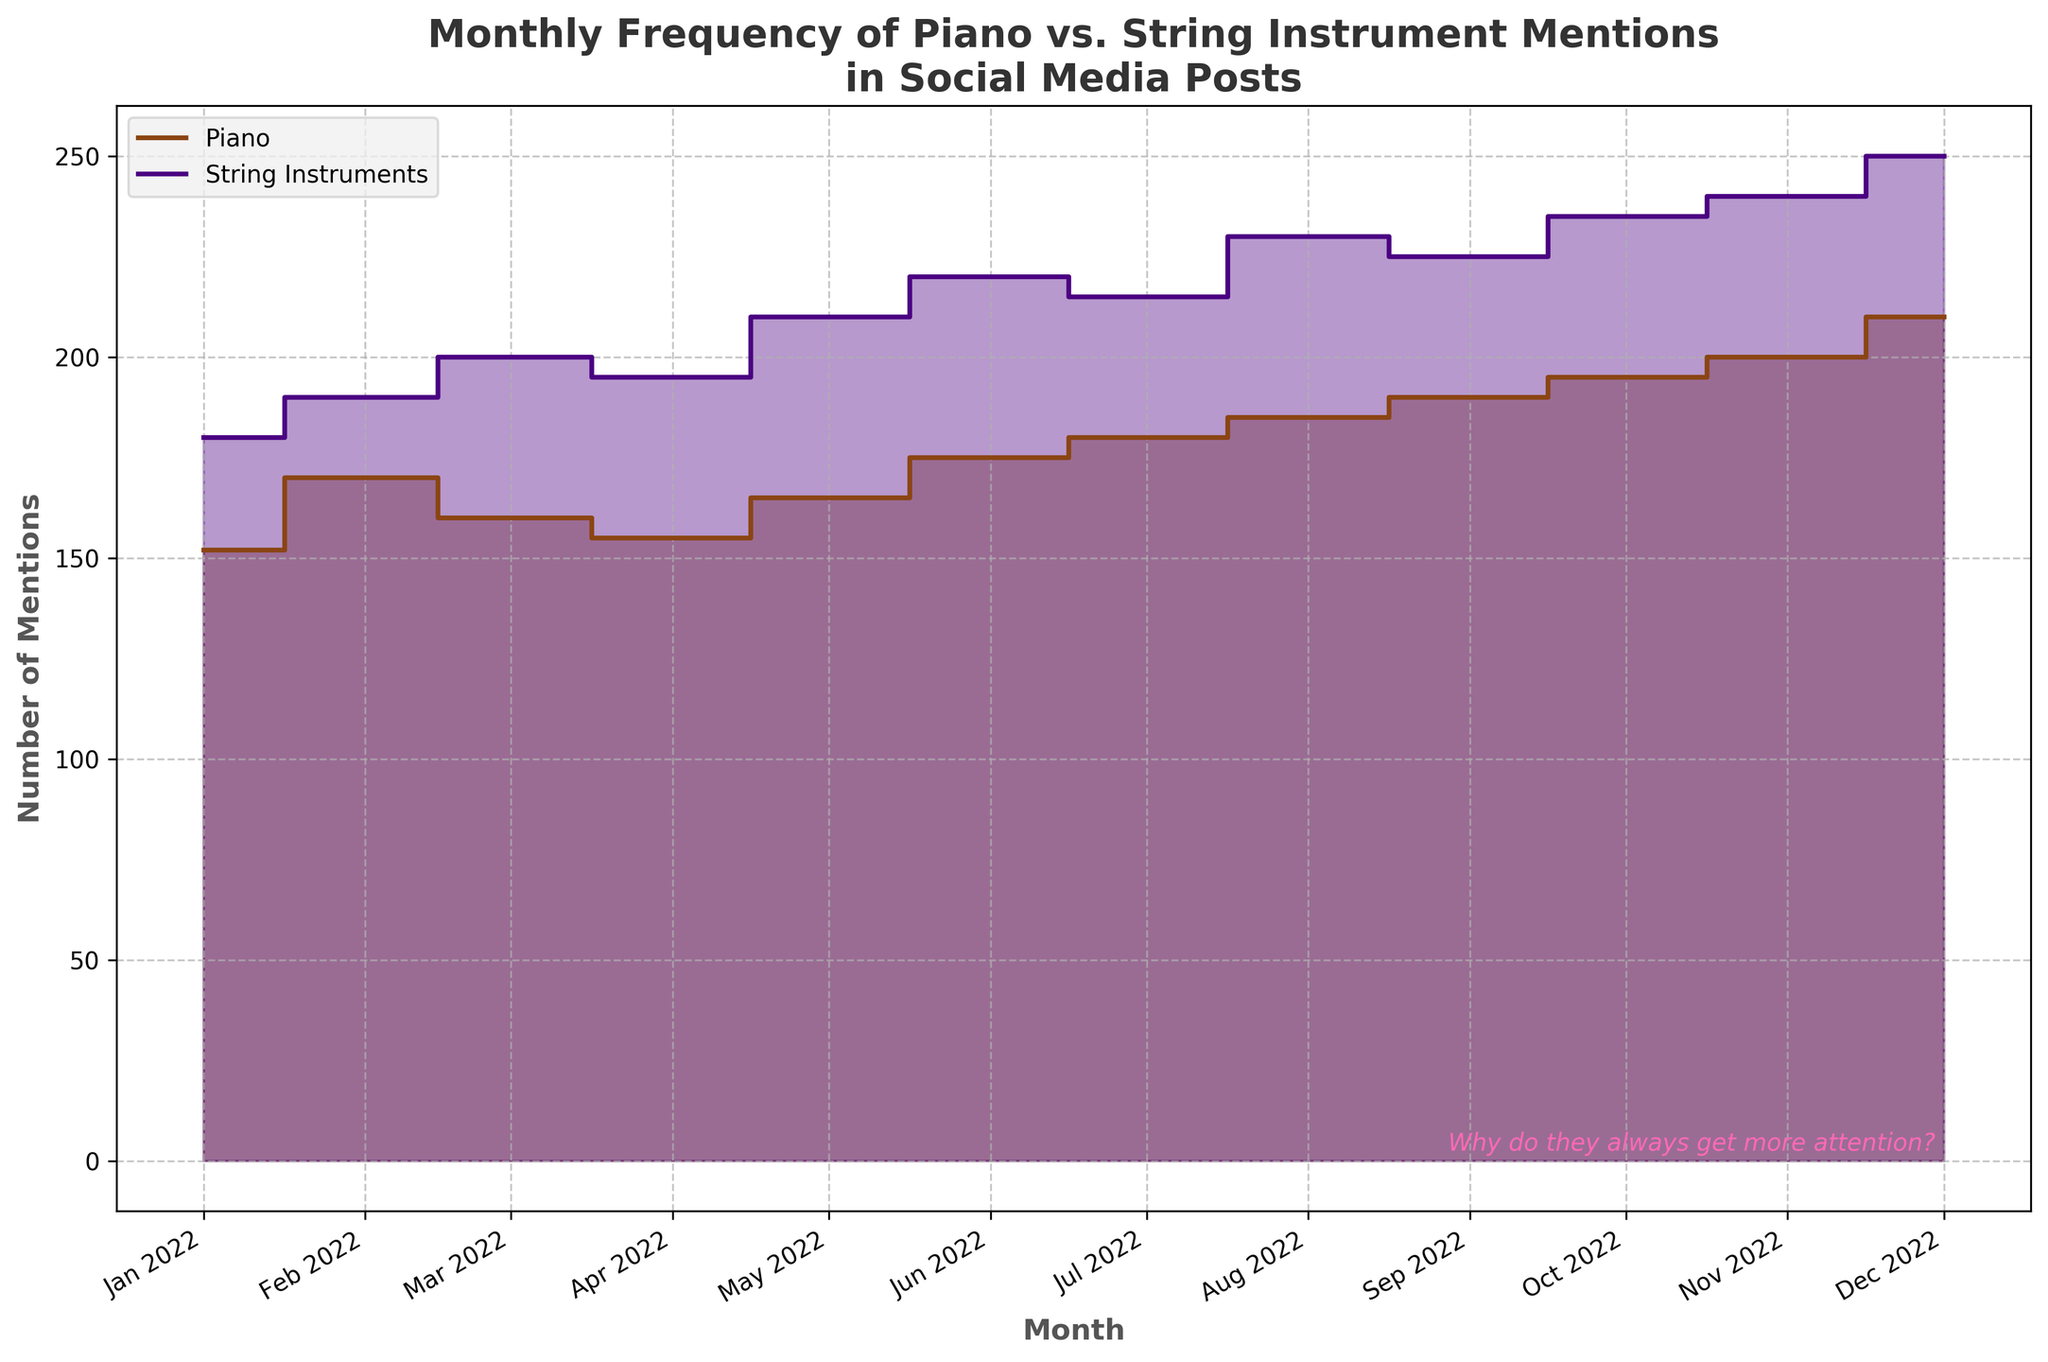What is the title of the chart? The title of the chart is usually at the top of the figure. In this case, it reads "Monthly Frequency of Piano vs. String Instrument Mentions in Social Media Posts".
Answer: Monthly Frequency of Piano vs. String Instrument Mentions in Social Media Posts Which month had the highest number of mentions for string instruments? The highest number of mentions is indicated by the peak of the purple step area, which occurs in December 2022.
Answer: December 2022 How many mentions did the piano have in June, and how does this compare to the string instruments in the same month? The number of mentions for piano in June is 175, while for string instruments, the number is 220. Comparing these values, we see that string instruments had more mentions.
Answer: Piano: 175, String Instruments: 220 What general trend can be observed for both piano and string instrument mentions over the year? Both piano and string instrument mentions show an increasing trend through the months. Observing the plot, the heights of both the brown step area (piano) and the purple step area (string instruments) generally rise as the months progress.
Answer: Increasing trend Which instrument category shows larger fluctuations in mentions throughout the year? By comparing the steepness and variations of the step areas, we can see that the string instruments (purple area) show larger changes between months compared to the piano mentions (brown area).
Answer: String instruments During which month did the difference between piano and string instrument mentions peak? To find the month with the largest difference, look for the greatest vertical distance between the purple and brown step areas. This occurs in December 2022, where string instruments have 250 mentions and piano has 210 mentions, a difference of 40.
Answer: December 2022 Calculate the average number of mentions for both piano and string instruments over the year. Sum the mentions for each category and divide by the number of months (12). For piano: (152 + 170 + 160 + 155 + 165 + 175 + 180 + 185 + 190 + 195 + 200 + 210) = 2237, so average is 2237/12 ≈ 186. For string instruments: (180 + 190 + 200 + 195 + 210 + 220 + 215 + 230 + 225 + 235 + 240 + 250) = 2590, so average is 2590/12 ≈ 216.
Answer: Piano: 186, String Instruments: 216 By how much did the mentions for piano increase from January to December? The mentions in January for piano were 152 and in December were 210. The increase is 210 - 152 = 58.
Answer: 58 What does the text at the bottom right of the chart express? The text reads "Why do they always get more attention?", which alludes to a sense of envy or frustration that the pianist feels about the string instruments receiving more mentions.
Answer: Why do they always get more attention? 